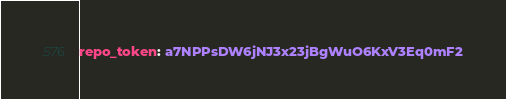<code> <loc_0><loc_0><loc_500><loc_500><_YAML_>repo_token: a7NPPsDW6jNJ3x23jBgWuO6KxV3Eq0mF2
</code> 